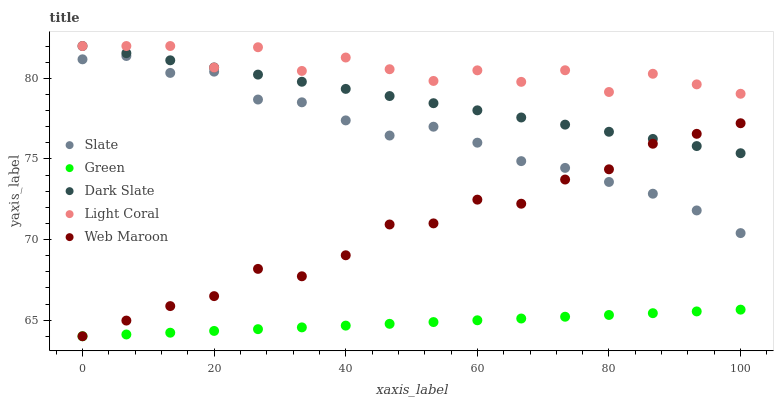Does Green have the minimum area under the curve?
Answer yes or no. Yes. Does Light Coral have the maximum area under the curve?
Answer yes or no. Yes. Does Dark Slate have the minimum area under the curve?
Answer yes or no. No. Does Dark Slate have the maximum area under the curve?
Answer yes or no. No. Is Green the smoothest?
Answer yes or no. Yes. Is Light Coral the roughest?
Answer yes or no. Yes. Is Dark Slate the smoothest?
Answer yes or no. No. Is Dark Slate the roughest?
Answer yes or no. No. Does Green have the lowest value?
Answer yes or no. Yes. Does Dark Slate have the lowest value?
Answer yes or no. No. Does Dark Slate have the highest value?
Answer yes or no. Yes. Does Slate have the highest value?
Answer yes or no. No. Is Slate less than Dark Slate?
Answer yes or no. Yes. Is Slate greater than Green?
Answer yes or no. Yes. Does Dark Slate intersect Web Maroon?
Answer yes or no. Yes. Is Dark Slate less than Web Maroon?
Answer yes or no. No. Is Dark Slate greater than Web Maroon?
Answer yes or no. No. Does Slate intersect Dark Slate?
Answer yes or no. No. 